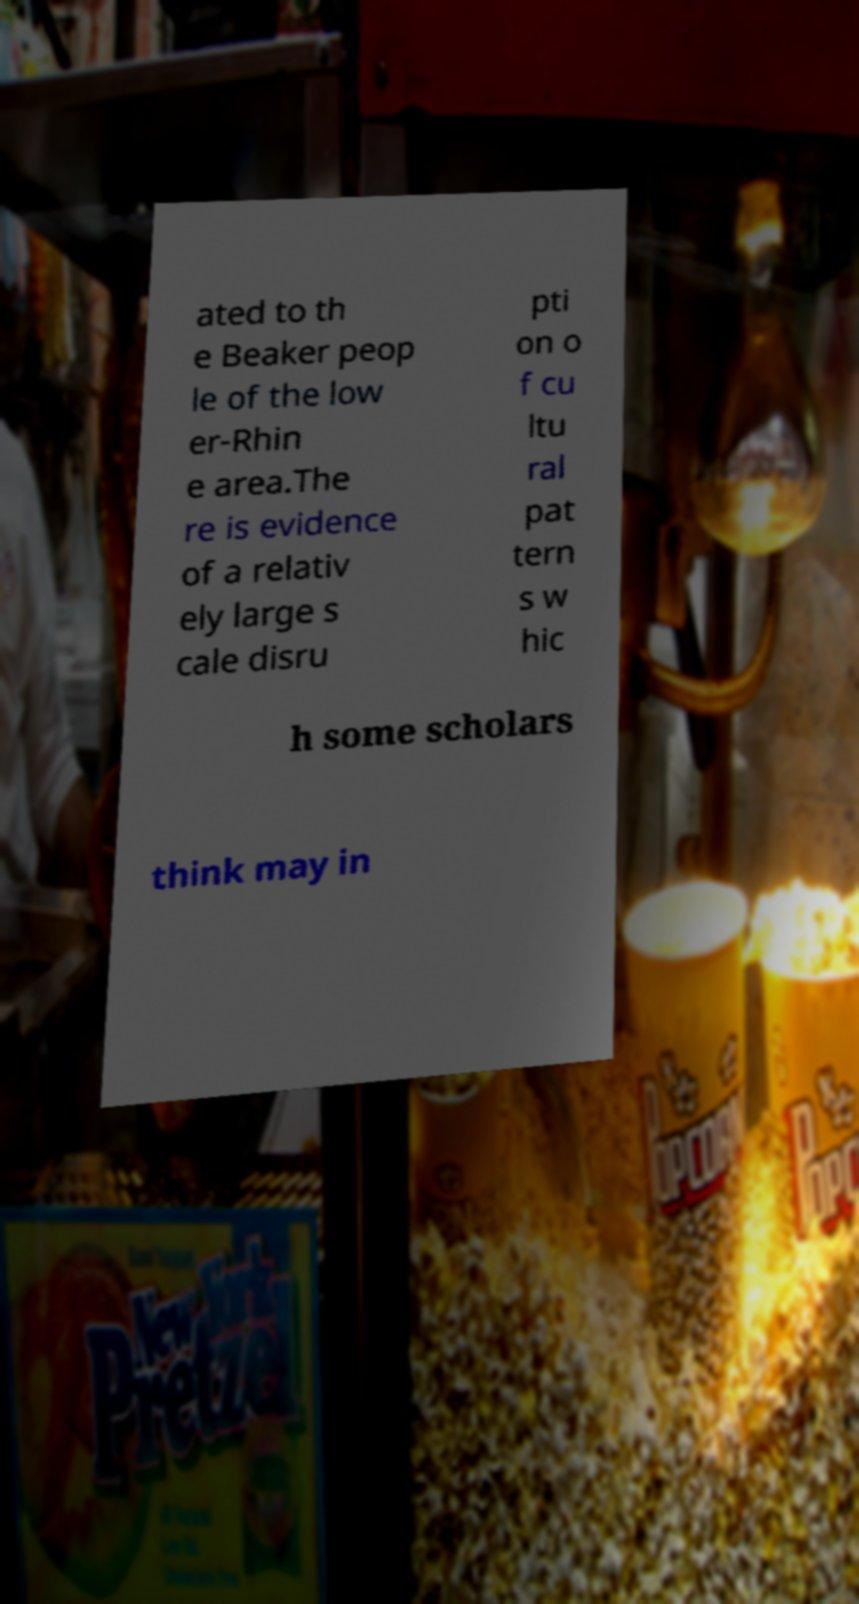Can you read and provide the text displayed in the image?This photo seems to have some interesting text. Can you extract and type it out for me? ated to th e Beaker peop le of the low er-Rhin e area.The re is evidence of a relativ ely large s cale disru pti on o f cu ltu ral pat tern s w hic h some scholars think may in 